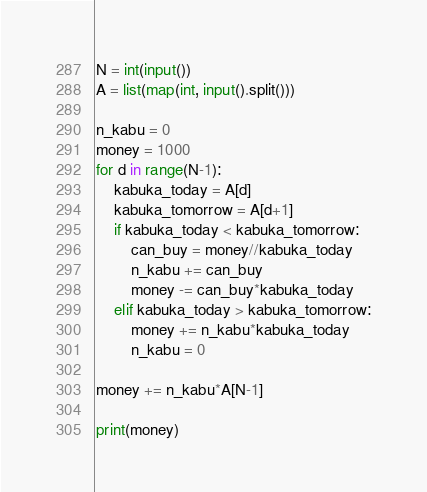<code> <loc_0><loc_0><loc_500><loc_500><_Python_>N = int(input())
A = list(map(int, input().split()))

n_kabu = 0
money = 1000
for d in range(N-1):
    kabuka_today = A[d]
    kabuka_tomorrow = A[d+1]
    if kabuka_today < kabuka_tomorrow:
        can_buy = money//kabuka_today
        n_kabu += can_buy
        money -= can_buy*kabuka_today
    elif kabuka_today > kabuka_tomorrow:
        money += n_kabu*kabuka_today
        n_kabu = 0

money += n_kabu*A[N-1]

print(money)</code> 